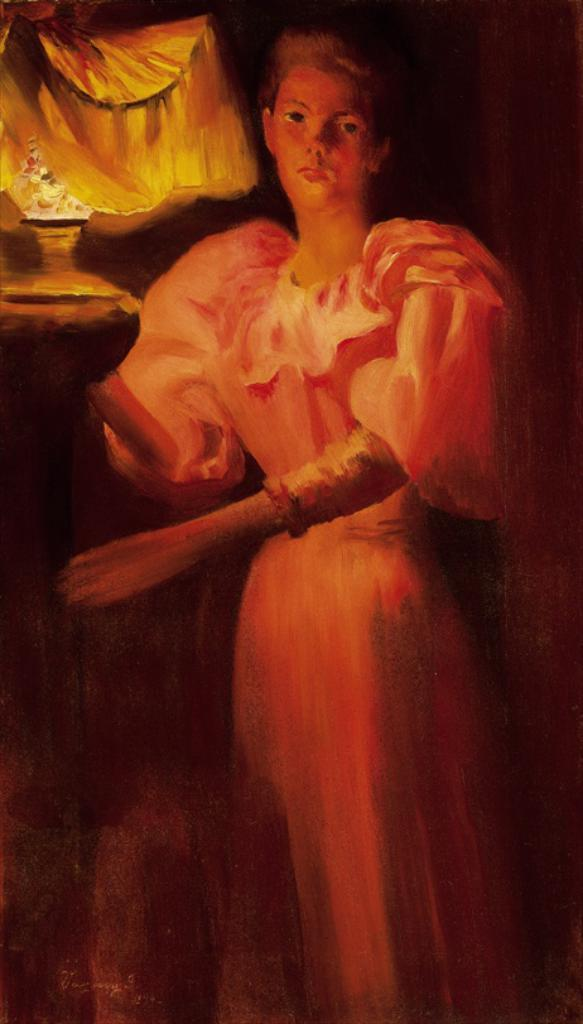What type of artwork is depicted in the image? The image is a painting. What figure can be seen in the painting? There is a woman standing in the painting. What object is also present in the painting? There is a pot in the painting. What type of meal is being prepared in the pot in the painting? There is no meal being prepared in the pot in the painting; it is just a pot. What religious symbolism can be found in the painting? There is no religious symbolism mentioned in the provided facts, so we cannot determine any religious aspects from the image. 